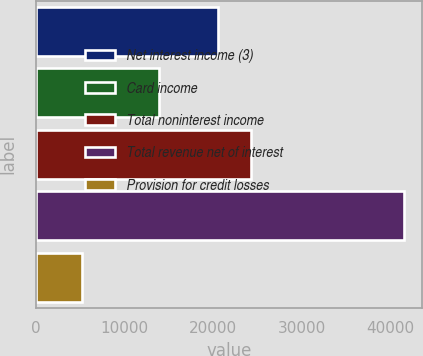Convert chart to OTSL. <chart><loc_0><loc_0><loc_500><loc_500><bar_chart><fcel>Net interest income (3)<fcel>Card income<fcel>Total noninterest income<fcel>Total revenue net of interest<fcel>Provision for credit losses<nl><fcel>20604<fcel>13940<fcel>24243.2<fcel>41564<fcel>5172<nl></chart> 